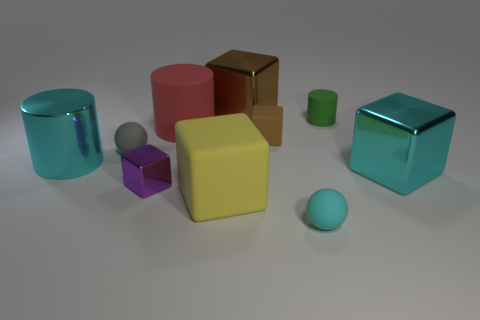Is the shape of the cyan rubber object the same as the big metallic thing behind the cyan cylinder?
Provide a succinct answer. No. What is the red thing that is in front of the big metallic cube behind the tiny brown thing made of?
Offer a terse response. Rubber. What number of other objects are the same shape as the tiny purple shiny object?
Keep it short and to the point. 4. Does the cyan metallic thing that is to the right of the gray ball have the same shape as the big cyan thing that is on the left side of the green rubber thing?
Give a very brief answer. No. What is the material of the gray object?
Your response must be concise. Rubber. There is a large thing right of the tiny rubber cylinder; what is its material?
Provide a short and direct response. Metal. Are there any other things of the same color as the small rubber cylinder?
Provide a short and direct response. No. There is a yellow thing that is the same material as the cyan ball; what size is it?
Your answer should be compact. Large. What number of small objects are gray things or cyan rubber things?
Give a very brief answer. 2. What size is the cyan shiny object that is right of the big cyan metal object left of the big matte object that is in front of the small brown block?
Provide a succinct answer. Large. 